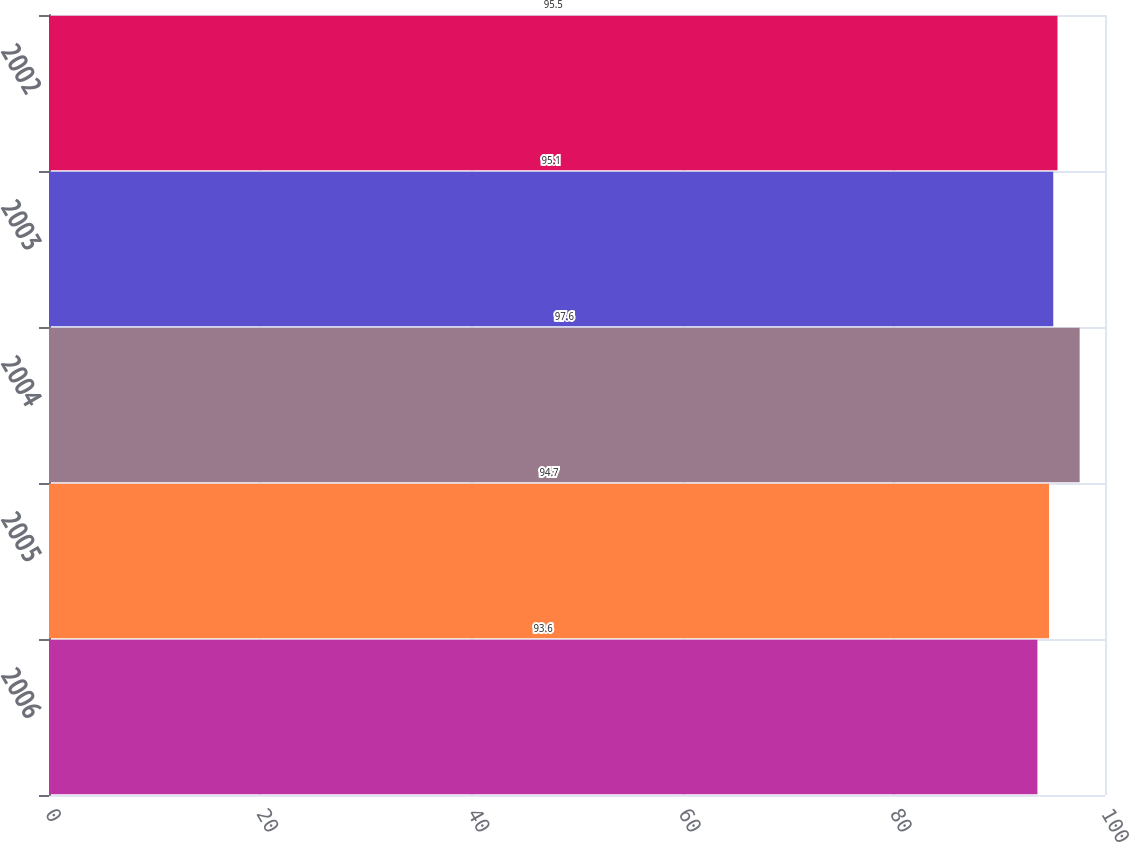Convert chart. <chart><loc_0><loc_0><loc_500><loc_500><bar_chart><fcel>2006<fcel>2005<fcel>2004<fcel>2003<fcel>2002<nl><fcel>93.6<fcel>94.7<fcel>97.6<fcel>95.1<fcel>95.5<nl></chart> 